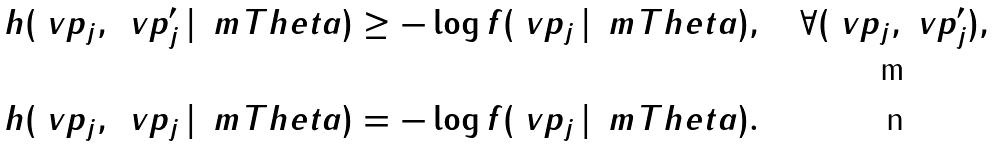<formula> <loc_0><loc_0><loc_500><loc_500>h ( \ v p _ { j } , \, \ v p _ { j } ^ { \prime } \, | \, \ m T h e t a ) & \geq - \log f ( \ v p _ { j } \, | \, \ m T h e t a ) , \quad \forall ( \ v p _ { j } , \ v p _ { j } ^ { \prime } ) , \\ h ( \ v p _ { j } , \, \ v p _ { j } \, | \, \ m T h e t a ) & = - \log f ( \ v p _ { j } \, | \, \ m T h e t a ) .</formula> 